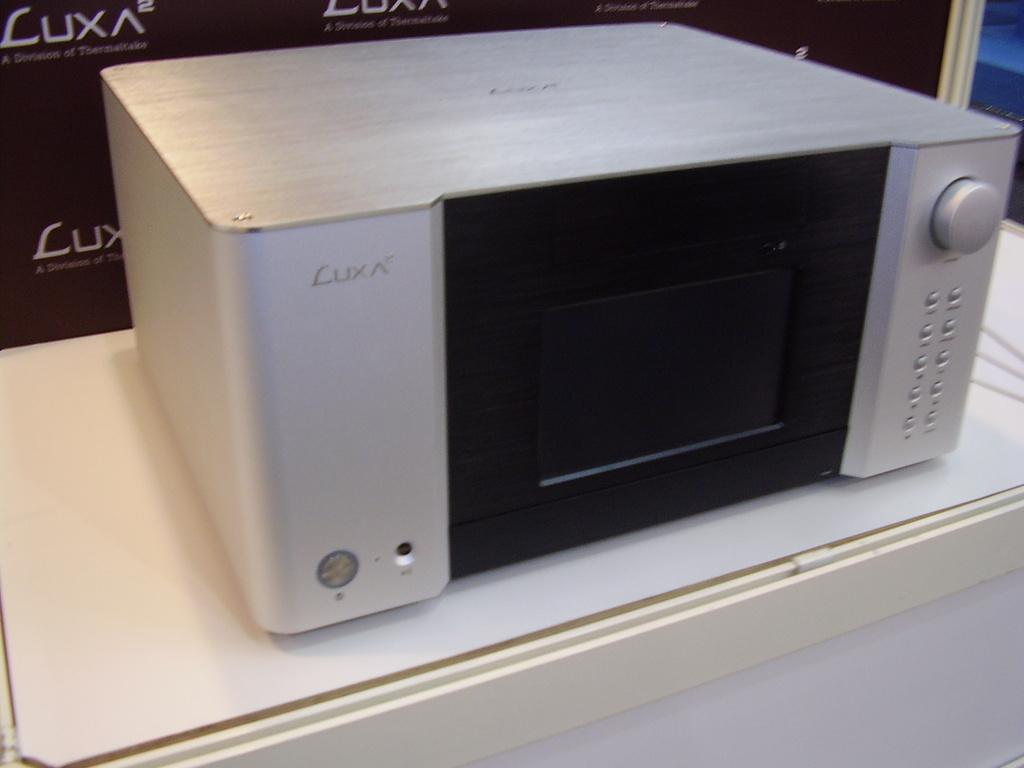Provide a one-sentence caption for the provided image. a LUX ^2 silver electronic gadget is on display at a shop. 